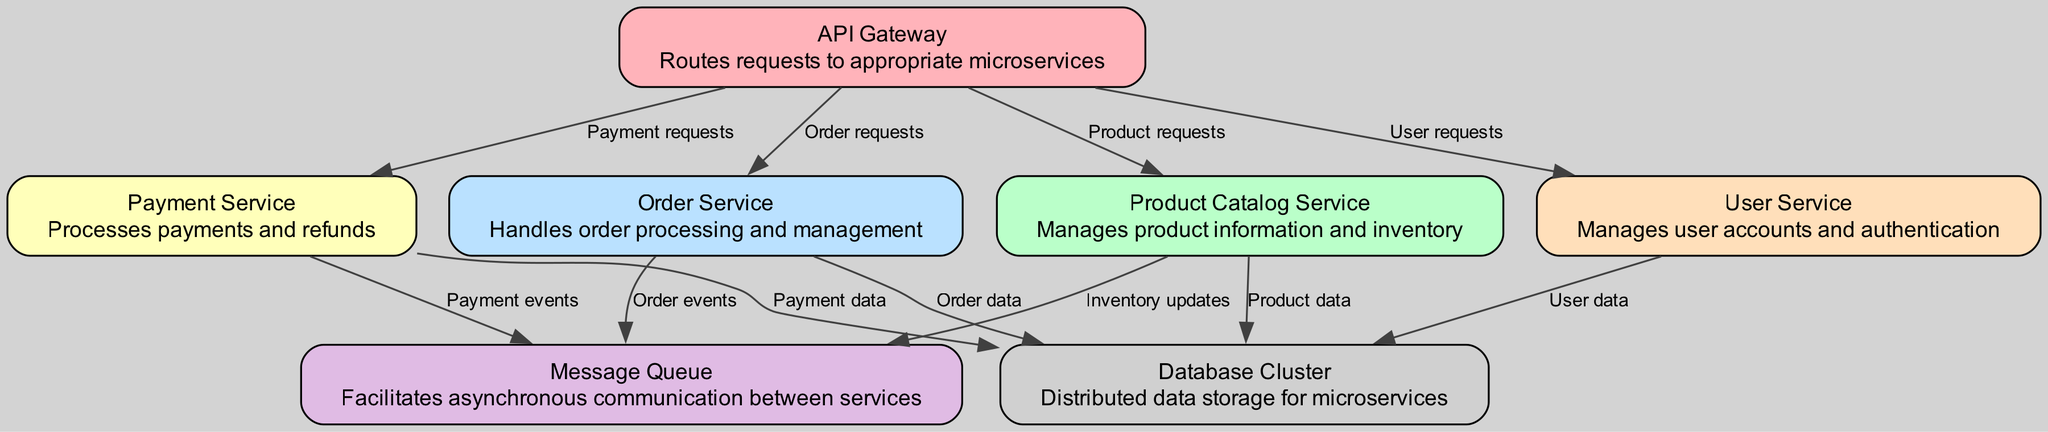What is the main role of the API Gateway? The API Gateway serves as the entry point for all client requests, routing them to the appropriate microservices based on the type of request.
Answer: Routes requests to appropriate microservices How many microservices are shown in the diagram? There are a total of five distinct microservices in the diagram: Product Catalog Service, Order Service, Payment Service, User Service, and Message Queue.
Answer: Five Which service handles order processing? The Order Service is responsible for handling all aspects of order processing and management.
Answer: Order Service What type of data does the Payment Service send to the Database Cluster? The Payment Service sends Payment data to the Database Cluster for storage and management of payment information.
Answer: Payment data How does the Product Catalog Service communicate with the Message Queue? The Product Catalog Service communicates with the Message Queue by sending inventory updates, which allow for asynchronous messaging and processing of inventory changes.
Answer: Inventory updates Which service is responsible for managing user accounts? The User Service is the designated microservice responsible for managing user accounts and authentication processes.
Answer: User Service What is the relationship between the Order Service and the Message Queue? The Order Service sends Order events to the Message Queue for asynchronous processing and communication of order status and updates.
Answer: Order events How does the API Gateway interact with the User Service? The API Gateway routes User requests to the User Service to manage user interactions and account information.
Answer: User requests What type of service is the Database Cluster? The Database Cluster is a distributed data storage service that supports the various microservices by providing persistent storage for their data requirements.
Answer: Distributed data storage 